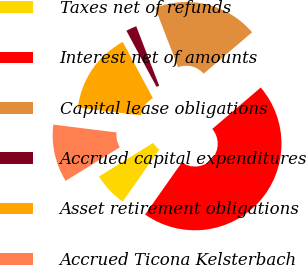<chart> <loc_0><loc_0><loc_500><loc_500><pie_chart><fcel>Taxes net of refunds<fcel>Interest net of amounts<fcel>Capital lease obligations<fcel>Accrued capital expenditures<fcel>Asset retirement obligations<fcel>Accrued Ticona Kelsterbach<nl><fcel>6.39%<fcel>46.02%<fcel>19.6%<fcel>1.99%<fcel>15.2%<fcel>10.8%<nl></chart> 